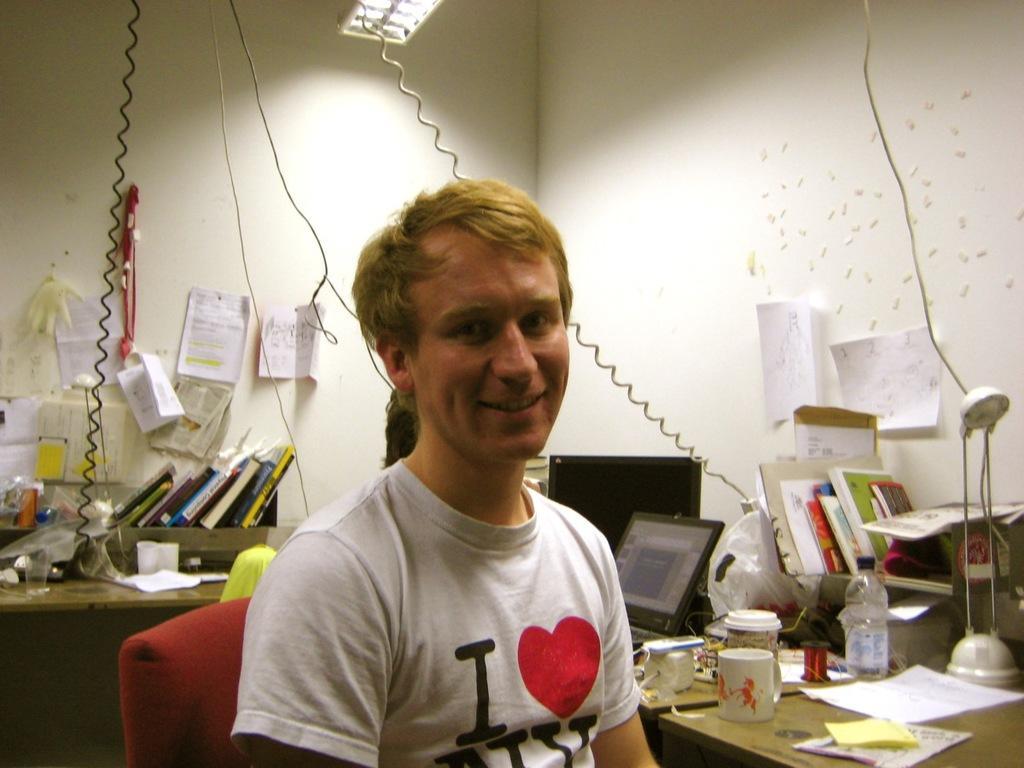Please provide a concise description of this image. In this picture I can see a laptop, few cups and a water bottle, books, a lamp on the table and I can see few papers on the walls with some text and I can see another table with books and a light to the ceiling and a man sitting on the chair. 